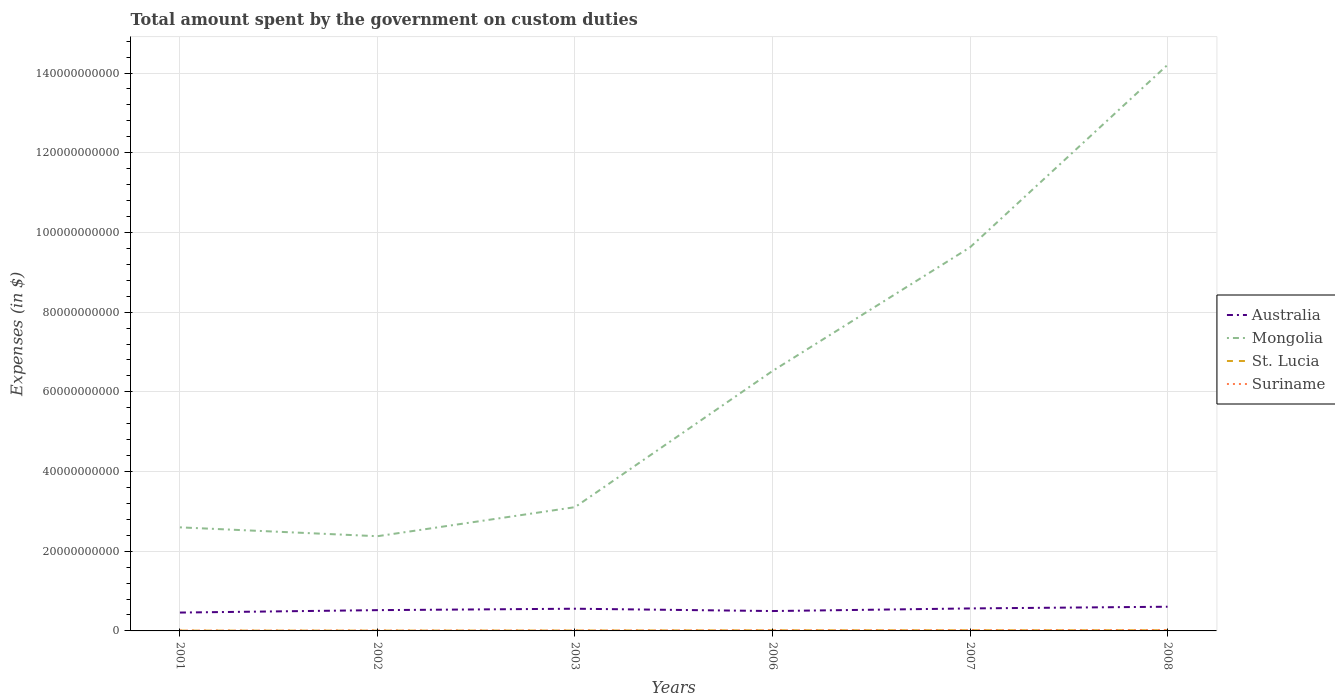How many different coloured lines are there?
Offer a very short reply. 4. Does the line corresponding to Australia intersect with the line corresponding to St. Lucia?
Give a very brief answer. No. Is the number of lines equal to the number of legend labels?
Ensure brevity in your answer.  Yes. Across all years, what is the maximum amount spent on custom duties by the government in Suriname?
Make the answer very short. 9.11e+07. In which year was the amount spent on custom duties by the government in St. Lucia maximum?
Your response must be concise. 2002. What is the total amount spent on custom duties by the government in Mongolia in the graph?
Offer a terse response. -1.18e+11. What is the difference between the highest and the second highest amount spent on custom duties by the government in Suriname?
Your answer should be very brief. 1.31e+08. What is the difference between the highest and the lowest amount spent on custom duties by the government in Suriname?
Give a very brief answer. 3. What is the difference between two consecutive major ticks on the Y-axis?
Your response must be concise. 2.00e+1. Where does the legend appear in the graph?
Make the answer very short. Center right. How are the legend labels stacked?
Your answer should be very brief. Vertical. What is the title of the graph?
Keep it short and to the point. Total amount spent by the government on custom duties. What is the label or title of the X-axis?
Your response must be concise. Years. What is the label or title of the Y-axis?
Your answer should be very brief. Expenses (in $). What is the Expenses (in $) in Australia in 2001?
Your answer should be very brief. 4.61e+09. What is the Expenses (in $) of Mongolia in 2001?
Ensure brevity in your answer.  2.60e+1. What is the Expenses (in $) of St. Lucia in 2001?
Provide a short and direct response. 8.25e+07. What is the Expenses (in $) of Suriname in 2001?
Ensure brevity in your answer.  9.11e+07. What is the Expenses (in $) in Australia in 2002?
Ensure brevity in your answer.  5.21e+09. What is the Expenses (in $) in Mongolia in 2002?
Provide a succinct answer. 2.38e+1. What is the Expenses (in $) in St. Lucia in 2002?
Your answer should be very brief. 8.15e+07. What is the Expenses (in $) in Suriname in 2002?
Provide a short and direct response. 1.07e+08. What is the Expenses (in $) in Australia in 2003?
Your answer should be very brief. 5.57e+09. What is the Expenses (in $) of Mongolia in 2003?
Your answer should be compact. 3.11e+1. What is the Expenses (in $) in St. Lucia in 2003?
Your answer should be very brief. 1.07e+08. What is the Expenses (in $) in Suriname in 2003?
Provide a succinct answer. 1.19e+08. What is the Expenses (in $) in Australia in 2006?
Your answer should be very brief. 4.99e+09. What is the Expenses (in $) of Mongolia in 2006?
Offer a very short reply. 6.52e+1. What is the Expenses (in $) of St. Lucia in 2006?
Provide a succinct answer. 1.60e+08. What is the Expenses (in $) in Suriname in 2006?
Keep it short and to the point. 1.60e+08. What is the Expenses (in $) in Australia in 2007?
Offer a terse response. 5.64e+09. What is the Expenses (in $) in Mongolia in 2007?
Give a very brief answer. 9.63e+1. What is the Expenses (in $) in St. Lucia in 2007?
Provide a succinct answer. 1.72e+08. What is the Expenses (in $) in Suriname in 2007?
Provide a succinct answer. 1.85e+08. What is the Expenses (in $) of Australia in 2008?
Your answer should be very brief. 6.07e+09. What is the Expenses (in $) in Mongolia in 2008?
Provide a succinct answer. 1.42e+11. What is the Expenses (in $) in St. Lucia in 2008?
Offer a very short reply. 1.75e+08. What is the Expenses (in $) in Suriname in 2008?
Make the answer very short. 2.22e+08. Across all years, what is the maximum Expenses (in $) in Australia?
Give a very brief answer. 6.07e+09. Across all years, what is the maximum Expenses (in $) of Mongolia?
Provide a succinct answer. 1.42e+11. Across all years, what is the maximum Expenses (in $) in St. Lucia?
Your answer should be very brief. 1.75e+08. Across all years, what is the maximum Expenses (in $) of Suriname?
Make the answer very short. 2.22e+08. Across all years, what is the minimum Expenses (in $) in Australia?
Offer a very short reply. 4.61e+09. Across all years, what is the minimum Expenses (in $) in Mongolia?
Your answer should be very brief. 2.38e+1. Across all years, what is the minimum Expenses (in $) of St. Lucia?
Your answer should be compact. 8.15e+07. Across all years, what is the minimum Expenses (in $) of Suriname?
Provide a short and direct response. 9.11e+07. What is the total Expenses (in $) in Australia in the graph?
Provide a succinct answer. 3.21e+1. What is the total Expenses (in $) of Mongolia in the graph?
Ensure brevity in your answer.  3.84e+11. What is the total Expenses (in $) in St. Lucia in the graph?
Give a very brief answer. 7.78e+08. What is the total Expenses (in $) of Suriname in the graph?
Keep it short and to the point. 8.84e+08. What is the difference between the Expenses (in $) of Australia in 2001 and that in 2002?
Ensure brevity in your answer.  -6.08e+08. What is the difference between the Expenses (in $) of Mongolia in 2001 and that in 2002?
Provide a succinct answer. 2.22e+09. What is the difference between the Expenses (in $) of St. Lucia in 2001 and that in 2002?
Make the answer very short. 1.00e+06. What is the difference between the Expenses (in $) in Suriname in 2001 and that in 2002?
Keep it short and to the point. -1.61e+07. What is the difference between the Expenses (in $) in Australia in 2001 and that in 2003?
Provide a short and direct response. -9.67e+08. What is the difference between the Expenses (in $) in Mongolia in 2001 and that in 2003?
Your response must be concise. -5.07e+09. What is the difference between the Expenses (in $) of St. Lucia in 2001 and that in 2003?
Ensure brevity in your answer.  -2.45e+07. What is the difference between the Expenses (in $) in Suriname in 2001 and that in 2003?
Your response must be concise. -2.77e+07. What is the difference between the Expenses (in $) of Australia in 2001 and that in 2006?
Give a very brief answer. -3.82e+08. What is the difference between the Expenses (in $) of Mongolia in 2001 and that in 2006?
Offer a terse response. -3.92e+1. What is the difference between the Expenses (in $) in St. Lucia in 2001 and that in 2006?
Your answer should be compact. -7.73e+07. What is the difference between the Expenses (in $) of Suriname in 2001 and that in 2006?
Keep it short and to the point. -6.90e+07. What is the difference between the Expenses (in $) of Australia in 2001 and that in 2007?
Make the answer very short. -1.04e+09. What is the difference between the Expenses (in $) of Mongolia in 2001 and that in 2007?
Your answer should be compact. -7.03e+1. What is the difference between the Expenses (in $) in St. Lucia in 2001 and that in 2007?
Provide a succinct answer. -8.96e+07. What is the difference between the Expenses (in $) in Suriname in 2001 and that in 2007?
Your answer should be very brief. -9.37e+07. What is the difference between the Expenses (in $) in Australia in 2001 and that in 2008?
Keep it short and to the point. -1.46e+09. What is the difference between the Expenses (in $) in Mongolia in 2001 and that in 2008?
Your response must be concise. -1.16e+11. What is the difference between the Expenses (in $) in St. Lucia in 2001 and that in 2008?
Your answer should be very brief. -9.29e+07. What is the difference between the Expenses (in $) of Suriname in 2001 and that in 2008?
Make the answer very short. -1.31e+08. What is the difference between the Expenses (in $) in Australia in 2002 and that in 2003?
Your response must be concise. -3.59e+08. What is the difference between the Expenses (in $) in Mongolia in 2002 and that in 2003?
Your answer should be very brief. -7.29e+09. What is the difference between the Expenses (in $) of St. Lucia in 2002 and that in 2003?
Ensure brevity in your answer.  -2.55e+07. What is the difference between the Expenses (in $) of Suriname in 2002 and that in 2003?
Provide a succinct answer. -1.16e+07. What is the difference between the Expenses (in $) of Australia in 2002 and that in 2006?
Offer a terse response. 2.26e+08. What is the difference between the Expenses (in $) of Mongolia in 2002 and that in 2006?
Provide a succinct answer. -4.15e+1. What is the difference between the Expenses (in $) in St. Lucia in 2002 and that in 2006?
Your answer should be very brief. -7.83e+07. What is the difference between the Expenses (in $) of Suriname in 2002 and that in 2006?
Provide a short and direct response. -5.29e+07. What is the difference between the Expenses (in $) of Australia in 2002 and that in 2007?
Provide a succinct answer. -4.30e+08. What is the difference between the Expenses (in $) of Mongolia in 2002 and that in 2007?
Give a very brief answer. -7.25e+1. What is the difference between the Expenses (in $) of St. Lucia in 2002 and that in 2007?
Offer a very short reply. -9.06e+07. What is the difference between the Expenses (in $) in Suriname in 2002 and that in 2007?
Your answer should be very brief. -7.76e+07. What is the difference between the Expenses (in $) in Australia in 2002 and that in 2008?
Give a very brief answer. -8.56e+08. What is the difference between the Expenses (in $) of Mongolia in 2002 and that in 2008?
Your answer should be compact. -1.18e+11. What is the difference between the Expenses (in $) of St. Lucia in 2002 and that in 2008?
Offer a terse response. -9.39e+07. What is the difference between the Expenses (in $) of Suriname in 2002 and that in 2008?
Offer a very short reply. -1.15e+08. What is the difference between the Expenses (in $) in Australia in 2003 and that in 2006?
Provide a short and direct response. 5.85e+08. What is the difference between the Expenses (in $) in Mongolia in 2003 and that in 2006?
Your response must be concise. -3.42e+1. What is the difference between the Expenses (in $) in St. Lucia in 2003 and that in 2006?
Provide a succinct answer. -5.28e+07. What is the difference between the Expenses (in $) of Suriname in 2003 and that in 2006?
Offer a terse response. -4.13e+07. What is the difference between the Expenses (in $) of Australia in 2003 and that in 2007?
Offer a very short reply. -7.10e+07. What is the difference between the Expenses (in $) in Mongolia in 2003 and that in 2007?
Ensure brevity in your answer.  -6.52e+1. What is the difference between the Expenses (in $) of St. Lucia in 2003 and that in 2007?
Your answer should be compact. -6.51e+07. What is the difference between the Expenses (in $) in Suriname in 2003 and that in 2007?
Give a very brief answer. -6.61e+07. What is the difference between the Expenses (in $) in Australia in 2003 and that in 2008?
Offer a terse response. -4.97e+08. What is the difference between the Expenses (in $) in Mongolia in 2003 and that in 2008?
Provide a succinct answer. -1.11e+11. What is the difference between the Expenses (in $) in St. Lucia in 2003 and that in 2008?
Keep it short and to the point. -6.84e+07. What is the difference between the Expenses (in $) of Suriname in 2003 and that in 2008?
Your answer should be compact. -1.03e+08. What is the difference between the Expenses (in $) in Australia in 2006 and that in 2007?
Offer a very short reply. -6.56e+08. What is the difference between the Expenses (in $) of Mongolia in 2006 and that in 2007?
Make the answer very short. -3.10e+1. What is the difference between the Expenses (in $) in St. Lucia in 2006 and that in 2007?
Your answer should be compact. -1.23e+07. What is the difference between the Expenses (in $) in Suriname in 2006 and that in 2007?
Your response must be concise. -2.47e+07. What is the difference between the Expenses (in $) of Australia in 2006 and that in 2008?
Provide a short and direct response. -1.08e+09. What is the difference between the Expenses (in $) of Mongolia in 2006 and that in 2008?
Provide a succinct answer. -7.68e+1. What is the difference between the Expenses (in $) in St. Lucia in 2006 and that in 2008?
Give a very brief answer. -1.56e+07. What is the difference between the Expenses (in $) in Suriname in 2006 and that in 2008?
Your answer should be very brief. -6.18e+07. What is the difference between the Expenses (in $) of Australia in 2007 and that in 2008?
Offer a terse response. -4.26e+08. What is the difference between the Expenses (in $) in Mongolia in 2007 and that in 2008?
Your answer should be compact. -4.58e+1. What is the difference between the Expenses (in $) in St. Lucia in 2007 and that in 2008?
Offer a terse response. -3.30e+06. What is the difference between the Expenses (in $) of Suriname in 2007 and that in 2008?
Your response must be concise. -3.71e+07. What is the difference between the Expenses (in $) of Australia in 2001 and the Expenses (in $) of Mongolia in 2002?
Keep it short and to the point. -1.92e+1. What is the difference between the Expenses (in $) of Australia in 2001 and the Expenses (in $) of St. Lucia in 2002?
Provide a succinct answer. 4.52e+09. What is the difference between the Expenses (in $) of Australia in 2001 and the Expenses (in $) of Suriname in 2002?
Your answer should be very brief. 4.50e+09. What is the difference between the Expenses (in $) in Mongolia in 2001 and the Expenses (in $) in St. Lucia in 2002?
Your response must be concise. 2.59e+1. What is the difference between the Expenses (in $) in Mongolia in 2001 and the Expenses (in $) in Suriname in 2002?
Offer a very short reply. 2.59e+1. What is the difference between the Expenses (in $) in St. Lucia in 2001 and the Expenses (in $) in Suriname in 2002?
Your response must be concise. -2.47e+07. What is the difference between the Expenses (in $) of Australia in 2001 and the Expenses (in $) of Mongolia in 2003?
Make the answer very short. -2.65e+1. What is the difference between the Expenses (in $) of Australia in 2001 and the Expenses (in $) of St. Lucia in 2003?
Offer a very short reply. 4.50e+09. What is the difference between the Expenses (in $) of Australia in 2001 and the Expenses (in $) of Suriname in 2003?
Provide a succinct answer. 4.49e+09. What is the difference between the Expenses (in $) of Mongolia in 2001 and the Expenses (in $) of St. Lucia in 2003?
Your response must be concise. 2.59e+1. What is the difference between the Expenses (in $) of Mongolia in 2001 and the Expenses (in $) of Suriname in 2003?
Your answer should be very brief. 2.59e+1. What is the difference between the Expenses (in $) of St. Lucia in 2001 and the Expenses (in $) of Suriname in 2003?
Provide a short and direct response. -3.62e+07. What is the difference between the Expenses (in $) in Australia in 2001 and the Expenses (in $) in Mongolia in 2006?
Your response must be concise. -6.06e+1. What is the difference between the Expenses (in $) in Australia in 2001 and the Expenses (in $) in St. Lucia in 2006?
Offer a very short reply. 4.45e+09. What is the difference between the Expenses (in $) of Australia in 2001 and the Expenses (in $) of Suriname in 2006?
Make the answer very short. 4.45e+09. What is the difference between the Expenses (in $) of Mongolia in 2001 and the Expenses (in $) of St. Lucia in 2006?
Keep it short and to the point. 2.58e+1. What is the difference between the Expenses (in $) of Mongolia in 2001 and the Expenses (in $) of Suriname in 2006?
Keep it short and to the point. 2.58e+1. What is the difference between the Expenses (in $) of St. Lucia in 2001 and the Expenses (in $) of Suriname in 2006?
Your answer should be very brief. -7.76e+07. What is the difference between the Expenses (in $) of Australia in 2001 and the Expenses (in $) of Mongolia in 2007?
Your response must be concise. -9.17e+1. What is the difference between the Expenses (in $) in Australia in 2001 and the Expenses (in $) in St. Lucia in 2007?
Your answer should be very brief. 4.43e+09. What is the difference between the Expenses (in $) of Australia in 2001 and the Expenses (in $) of Suriname in 2007?
Your answer should be very brief. 4.42e+09. What is the difference between the Expenses (in $) of Mongolia in 2001 and the Expenses (in $) of St. Lucia in 2007?
Offer a very short reply. 2.58e+1. What is the difference between the Expenses (in $) of Mongolia in 2001 and the Expenses (in $) of Suriname in 2007?
Your response must be concise. 2.58e+1. What is the difference between the Expenses (in $) of St. Lucia in 2001 and the Expenses (in $) of Suriname in 2007?
Give a very brief answer. -1.02e+08. What is the difference between the Expenses (in $) of Australia in 2001 and the Expenses (in $) of Mongolia in 2008?
Keep it short and to the point. -1.37e+11. What is the difference between the Expenses (in $) in Australia in 2001 and the Expenses (in $) in St. Lucia in 2008?
Keep it short and to the point. 4.43e+09. What is the difference between the Expenses (in $) of Australia in 2001 and the Expenses (in $) of Suriname in 2008?
Make the answer very short. 4.38e+09. What is the difference between the Expenses (in $) in Mongolia in 2001 and the Expenses (in $) in St. Lucia in 2008?
Provide a succinct answer. 2.58e+1. What is the difference between the Expenses (in $) in Mongolia in 2001 and the Expenses (in $) in Suriname in 2008?
Your response must be concise. 2.58e+1. What is the difference between the Expenses (in $) in St. Lucia in 2001 and the Expenses (in $) in Suriname in 2008?
Give a very brief answer. -1.39e+08. What is the difference between the Expenses (in $) of Australia in 2002 and the Expenses (in $) of Mongolia in 2003?
Provide a succinct answer. -2.58e+1. What is the difference between the Expenses (in $) of Australia in 2002 and the Expenses (in $) of St. Lucia in 2003?
Your response must be concise. 5.11e+09. What is the difference between the Expenses (in $) in Australia in 2002 and the Expenses (in $) in Suriname in 2003?
Make the answer very short. 5.10e+09. What is the difference between the Expenses (in $) of Mongolia in 2002 and the Expenses (in $) of St. Lucia in 2003?
Keep it short and to the point. 2.37e+1. What is the difference between the Expenses (in $) of Mongolia in 2002 and the Expenses (in $) of Suriname in 2003?
Your answer should be very brief. 2.36e+1. What is the difference between the Expenses (in $) in St. Lucia in 2002 and the Expenses (in $) in Suriname in 2003?
Your response must be concise. -3.72e+07. What is the difference between the Expenses (in $) in Australia in 2002 and the Expenses (in $) in Mongolia in 2006?
Ensure brevity in your answer.  -6.00e+1. What is the difference between the Expenses (in $) in Australia in 2002 and the Expenses (in $) in St. Lucia in 2006?
Your answer should be compact. 5.05e+09. What is the difference between the Expenses (in $) of Australia in 2002 and the Expenses (in $) of Suriname in 2006?
Give a very brief answer. 5.05e+09. What is the difference between the Expenses (in $) of Mongolia in 2002 and the Expenses (in $) of St. Lucia in 2006?
Your answer should be very brief. 2.36e+1. What is the difference between the Expenses (in $) of Mongolia in 2002 and the Expenses (in $) of Suriname in 2006?
Give a very brief answer. 2.36e+1. What is the difference between the Expenses (in $) of St. Lucia in 2002 and the Expenses (in $) of Suriname in 2006?
Make the answer very short. -7.86e+07. What is the difference between the Expenses (in $) of Australia in 2002 and the Expenses (in $) of Mongolia in 2007?
Provide a succinct answer. -9.10e+1. What is the difference between the Expenses (in $) of Australia in 2002 and the Expenses (in $) of St. Lucia in 2007?
Offer a terse response. 5.04e+09. What is the difference between the Expenses (in $) of Australia in 2002 and the Expenses (in $) of Suriname in 2007?
Keep it short and to the point. 5.03e+09. What is the difference between the Expenses (in $) of Mongolia in 2002 and the Expenses (in $) of St. Lucia in 2007?
Ensure brevity in your answer.  2.36e+1. What is the difference between the Expenses (in $) of Mongolia in 2002 and the Expenses (in $) of Suriname in 2007?
Provide a short and direct response. 2.36e+1. What is the difference between the Expenses (in $) in St. Lucia in 2002 and the Expenses (in $) in Suriname in 2007?
Offer a very short reply. -1.03e+08. What is the difference between the Expenses (in $) of Australia in 2002 and the Expenses (in $) of Mongolia in 2008?
Offer a terse response. -1.37e+11. What is the difference between the Expenses (in $) of Australia in 2002 and the Expenses (in $) of St. Lucia in 2008?
Offer a very short reply. 5.04e+09. What is the difference between the Expenses (in $) in Australia in 2002 and the Expenses (in $) in Suriname in 2008?
Give a very brief answer. 4.99e+09. What is the difference between the Expenses (in $) in Mongolia in 2002 and the Expenses (in $) in St. Lucia in 2008?
Make the answer very short. 2.36e+1. What is the difference between the Expenses (in $) of Mongolia in 2002 and the Expenses (in $) of Suriname in 2008?
Offer a terse response. 2.35e+1. What is the difference between the Expenses (in $) of St. Lucia in 2002 and the Expenses (in $) of Suriname in 2008?
Provide a succinct answer. -1.40e+08. What is the difference between the Expenses (in $) of Australia in 2003 and the Expenses (in $) of Mongolia in 2006?
Your answer should be very brief. -5.97e+1. What is the difference between the Expenses (in $) in Australia in 2003 and the Expenses (in $) in St. Lucia in 2006?
Your answer should be compact. 5.41e+09. What is the difference between the Expenses (in $) of Australia in 2003 and the Expenses (in $) of Suriname in 2006?
Give a very brief answer. 5.41e+09. What is the difference between the Expenses (in $) in Mongolia in 2003 and the Expenses (in $) in St. Lucia in 2006?
Make the answer very short. 3.09e+1. What is the difference between the Expenses (in $) of Mongolia in 2003 and the Expenses (in $) of Suriname in 2006?
Make the answer very short. 3.09e+1. What is the difference between the Expenses (in $) in St. Lucia in 2003 and the Expenses (in $) in Suriname in 2006?
Provide a short and direct response. -5.31e+07. What is the difference between the Expenses (in $) in Australia in 2003 and the Expenses (in $) in Mongolia in 2007?
Provide a short and direct response. -9.07e+1. What is the difference between the Expenses (in $) of Australia in 2003 and the Expenses (in $) of St. Lucia in 2007?
Offer a very short reply. 5.40e+09. What is the difference between the Expenses (in $) in Australia in 2003 and the Expenses (in $) in Suriname in 2007?
Provide a succinct answer. 5.39e+09. What is the difference between the Expenses (in $) in Mongolia in 2003 and the Expenses (in $) in St. Lucia in 2007?
Offer a very short reply. 3.09e+1. What is the difference between the Expenses (in $) in Mongolia in 2003 and the Expenses (in $) in Suriname in 2007?
Provide a short and direct response. 3.09e+1. What is the difference between the Expenses (in $) in St. Lucia in 2003 and the Expenses (in $) in Suriname in 2007?
Make the answer very short. -7.78e+07. What is the difference between the Expenses (in $) of Australia in 2003 and the Expenses (in $) of Mongolia in 2008?
Your answer should be very brief. -1.36e+11. What is the difference between the Expenses (in $) in Australia in 2003 and the Expenses (in $) in St. Lucia in 2008?
Ensure brevity in your answer.  5.40e+09. What is the difference between the Expenses (in $) in Australia in 2003 and the Expenses (in $) in Suriname in 2008?
Keep it short and to the point. 5.35e+09. What is the difference between the Expenses (in $) of Mongolia in 2003 and the Expenses (in $) of St. Lucia in 2008?
Your response must be concise. 3.09e+1. What is the difference between the Expenses (in $) of Mongolia in 2003 and the Expenses (in $) of Suriname in 2008?
Your answer should be compact. 3.08e+1. What is the difference between the Expenses (in $) in St. Lucia in 2003 and the Expenses (in $) in Suriname in 2008?
Provide a short and direct response. -1.15e+08. What is the difference between the Expenses (in $) of Australia in 2006 and the Expenses (in $) of Mongolia in 2007?
Give a very brief answer. -9.13e+1. What is the difference between the Expenses (in $) of Australia in 2006 and the Expenses (in $) of St. Lucia in 2007?
Make the answer very short. 4.82e+09. What is the difference between the Expenses (in $) of Australia in 2006 and the Expenses (in $) of Suriname in 2007?
Give a very brief answer. 4.80e+09. What is the difference between the Expenses (in $) in Mongolia in 2006 and the Expenses (in $) in St. Lucia in 2007?
Your response must be concise. 6.51e+1. What is the difference between the Expenses (in $) in Mongolia in 2006 and the Expenses (in $) in Suriname in 2007?
Your answer should be very brief. 6.50e+1. What is the difference between the Expenses (in $) in St. Lucia in 2006 and the Expenses (in $) in Suriname in 2007?
Your answer should be very brief. -2.50e+07. What is the difference between the Expenses (in $) in Australia in 2006 and the Expenses (in $) in Mongolia in 2008?
Ensure brevity in your answer.  -1.37e+11. What is the difference between the Expenses (in $) in Australia in 2006 and the Expenses (in $) in St. Lucia in 2008?
Make the answer very short. 4.81e+09. What is the difference between the Expenses (in $) in Australia in 2006 and the Expenses (in $) in Suriname in 2008?
Offer a terse response. 4.77e+09. What is the difference between the Expenses (in $) of Mongolia in 2006 and the Expenses (in $) of St. Lucia in 2008?
Offer a terse response. 6.51e+1. What is the difference between the Expenses (in $) in Mongolia in 2006 and the Expenses (in $) in Suriname in 2008?
Your answer should be very brief. 6.50e+1. What is the difference between the Expenses (in $) of St. Lucia in 2006 and the Expenses (in $) of Suriname in 2008?
Ensure brevity in your answer.  -6.21e+07. What is the difference between the Expenses (in $) in Australia in 2007 and the Expenses (in $) in Mongolia in 2008?
Ensure brevity in your answer.  -1.36e+11. What is the difference between the Expenses (in $) of Australia in 2007 and the Expenses (in $) of St. Lucia in 2008?
Your response must be concise. 5.47e+09. What is the difference between the Expenses (in $) in Australia in 2007 and the Expenses (in $) in Suriname in 2008?
Your answer should be very brief. 5.42e+09. What is the difference between the Expenses (in $) in Mongolia in 2007 and the Expenses (in $) in St. Lucia in 2008?
Make the answer very short. 9.61e+1. What is the difference between the Expenses (in $) of Mongolia in 2007 and the Expenses (in $) of Suriname in 2008?
Give a very brief answer. 9.60e+1. What is the difference between the Expenses (in $) in St. Lucia in 2007 and the Expenses (in $) in Suriname in 2008?
Keep it short and to the point. -4.98e+07. What is the average Expenses (in $) of Australia per year?
Your response must be concise. 5.35e+09. What is the average Expenses (in $) in Mongolia per year?
Provide a succinct answer. 6.41e+1. What is the average Expenses (in $) in St. Lucia per year?
Give a very brief answer. 1.30e+08. What is the average Expenses (in $) of Suriname per year?
Offer a very short reply. 1.47e+08. In the year 2001, what is the difference between the Expenses (in $) of Australia and Expenses (in $) of Mongolia?
Keep it short and to the point. -2.14e+1. In the year 2001, what is the difference between the Expenses (in $) of Australia and Expenses (in $) of St. Lucia?
Your response must be concise. 4.52e+09. In the year 2001, what is the difference between the Expenses (in $) of Australia and Expenses (in $) of Suriname?
Your answer should be very brief. 4.51e+09. In the year 2001, what is the difference between the Expenses (in $) in Mongolia and Expenses (in $) in St. Lucia?
Ensure brevity in your answer.  2.59e+1. In the year 2001, what is the difference between the Expenses (in $) of Mongolia and Expenses (in $) of Suriname?
Ensure brevity in your answer.  2.59e+1. In the year 2001, what is the difference between the Expenses (in $) of St. Lucia and Expenses (in $) of Suriname?
Keep it short and to the point. -8.56e+06. In the year 2002, what is the difference between the Expenses (in $) in Australia and Expenses (in $) in Mongolia?
Offer a very short reply. -1.86e+1. In the year 2002, what is the difference between the Expenses (in $) in Australia and Expenses (in $) in St. Lucia?
Make the answer very short. 5.13e+09. In the year 2002, what is the difference between the Expenses (in $) in Australia and Expenses (in $) in Suriname?
Keep it short and to the point. 5.11e+09. In the year 2002, what is the difference between the Expenses (in $) in Mongolia and Expenses (in $) in St. Lucia?
Provide a succinct answer. 2.37e+1. In the year 2002, what is the difference between the Expenses (in $) in Mongolia and Expenses (in $) in Suriname?
Ensure brevity in your answer.  2.37e+1. In the year 2002, what is the difference between the Expenses (in $) of St. Lucia and Expenses (in $) of Suriname?
Keep it short and to the point. -2.57e+07. In the year 2003, what is the difference between the Expenses (in $) in Australia and Expenses (in $) in Mongolia?
Provide a short and direct response. -2.55e+1. In the year 2003, what is the difference between the Expenses (in $) of Australia and Expenses (in $) of St. Lucia?
Your answer should be compact. 5.47e+09. In the year 2003, what is the difference between the Expenses (in $) of Australia and Expenses (in $) of Suriname?
Give a very brief answer. 5.45e+09. In the year 2003, what is the difference between the Expenses (in $) of Mongolia and Expenses (in $) of St. Lucia?
Provide a short and direct response. 3.10e+1. In the year 2003, what is the difference between the Expenses (in $) of Mongolia and Expenses (in $) of Suriname?
Your answer should be compact. 3.09e+1. In the year 2003, what is the difference between the Expenses (in $) of St. Lucia and Expenses (in $) of Suriname?
Keep it short and to the point. -1.17e+07. In the year 2006, what is the difference between the Expenses (in $) of Australia and Expenses (in $) of Mongolia?
Provide a short and direct response. -6.02e+1. In the year 2006, what is the difference between the Expenses (in $) in Australia and Expenses (in $) in St. Lucia?
Make the answer very short. 4.83e+09. In the year 2006, what is the difference between the Expenses (in $) in Australia and Expenses (in $) in Suriname?
Your answer should be compact. 4.83e+09. In the year 2006, what is the difference between the Expenses (in $) in Mongolia and Expenses (in $) in St. Lucia?
Ensure brevity in your answer.  6.51e+1. In the year 2006, what is the difference between the Expenses (in $) of Mongolia and Expenses (in $) of Suriname?
Provide a succinct answer. 6.51e+1. In the year 2006, what is the difference between the Expenses (in $) in St. Lucia and Expenses (in $) in Suriname?
Offer a very short reply. -2.60e+05. In the year 2007, what is the difference between the Expenses (in $) of Australia and Expenses (in $) of Mongolia?
Keep it short and to the point. -9.06e+1. In the year 2007, what is the difference between the Expenses (in $) in Australia and Expenses (in $) in St. Lucia?
Your response must be concise. 5.47e+09. In the year 2007, what is the difference between the Expenses (in $) in Australia and Expenses (in $) in Suriname?
Make the answer very short. 5.46e+09. In the year 2007, what is the difference between the Expenses (in $) of Mongolia and Expenses (in $) of St. Lucia?
Keep it short and to the point. 9.61e+1. In the year 2007, what is the difference between the Expenses (in $) in Mongolia and Expenses (in $) in Suriname?
Provide a short and direct response. 9.61e+1. In the year 2007, what is the difference between the Expenses (in $) in St. Lucia and Expenses (in $) in Suriname?
Your answer should be very brief. -1.27e+07. In the year 2008, what is the difference between the Expenses (in $) of Australia and Expenses (in $) of Mongolia?
Make the answer very short. -1.36e+11. In the year 2008, what is the difference between the Expenses (in $) of Australia and Expenses (in $) of St. Lucia?
Your answer should be very brief. 5.89e+09. In the year 2008, what is the difference between the Expenses (in $) of Australia and Expenses (in $) of Suriname?
Make the answer very short. 5.85e+09. In the year 2008, what is the difference between the Expenses (in $) in Mongolia and Expenses (in $) in St. Lucia?
Give a very brief answer. 1.42e+11. In the year 2008, what is the difference between the Expenses (in $) in Mongolia and Expenses (in $) in Suriname?
Give a very brief answer. 1.42e+11. In the year 2008, what is the difference between the Expenses (in $) of St. Lucia and Expenses (in $) of Suriname?
Offer a very short reply. -4.65e+07. What is the ratio of the Expenses (in $) in Australia in 2001 to that in 2002?
Give a very brief answer. 0.88. What is the ratio of the Expenses (in $) in Mongolia in 2001 to that in 2002?
Provide a succinct answer. 1.09. What is the ratio of the Expenses (in $) in St. Lucia in 2001 to that in 2002?
Your answer should be compact. 1.01. What is the ratio of the Expenses (in $) of Suriname in 2001 to that in 2002?
Offer a terse response. 0.85. What is the ratio of the Expenses (in $) of Australia in 2001 to that in 2003?
Your answer should be compact. 0.83. What is the ratio of the Expenses (in $) in Mongolia in 2001 to that in 2003?
Provide a short and direct response. 0.84. What is the ratio of the Expenses (in $) in St. Lucia in 2001 to that in 2003?
Your answer should be very brief. 0.77. What is the ratio of the Expenses (in $) of Suriname in 2001 to that in 2003?
Offer a terse response. 0.77. What is the ratio of the Expenses (in $) in Australia in 2001 to that in 2006?
Make the answer very short. 0.92. What is the ratio of the Expenses (in $) of Mongolia in 2001 to that in 2006?
Your answer should be very brief. 0.4. What is the ratio of the Expenses (in $) of St. Lucia in 2001 to that in 2006?
Your answer should be compact. 0.52. What is the ratio of the Expenses (in $) of Suriname in 2001 to that in 2006?
Ensure brevity in your answer.  0.57. What is the ratio of the Expenses (in $) of Australia in 2001 to that in 2007?
Make the answer very short. 0.82. What is the ratio of the Expenses (in $) of Mongolia in 2001 to that in 2007?
Offer a terse response. 0.27. What is the ratio of the Expenses (in $) in St. Lucia in 2001 to that in 2007?
Keep it short and to the point. 0.48. What is the ratio of the Expenses (in $) in Suriname in 2001 to that in 2007?
Offer a very short reply. 0.49. What is the ratio of the Expenses (in $) of Australia in 2001 to that in 2008?
Provide a succinct answer. 0.76. What is the ratio of the Expenses (in $) of Mongolia in 2001 to that in 2008?
Your answer should be very brief. 0.18. What is the ratio of the Expenses (in $) in St. Lucia in 2001 to that in 2008?
Keep it short and to the point. 0.47. What is the ratio of the Expenses (in $) of Suriname in 2001 to that in 2008?
Your answer should be compact. 0.41. What is the ratio of the Expenses (in $) in Australia in 2002 to that in 2003?
Offer a very short reply. 0.94. What is the ratio of the Expenses (in $) in Mongolia in 2002 to that in 2003?
Provide a short and direct response. 0.77. What is the ratio of the Expenses (in $) of St. Lucia in 2002 to that in 2003?
Offer a very short reply. 0.76. What is the ratio of the Expenses (in $) in Suriname in 2002 to that in 2003?
Your answer should be very brief. 0.9. What is the ratio of the Expenses (in $) in Australia in 2002 to that in 2006?
Your response must be concise. 1.05. What is the ratio of the Expenses (in $) in Mongolia in 2002 to that in 2006?
Your response must be concise. 0.36. What is the ratio of the Expenses (in $) in St. Lucia in 2002 to that in 2006?
Give a very brief answer. 0.51. What is the ratio of the Expenses (in $) of Suriname in 2002 to that in 2006?
Your answer should be compact. 0.67. What is the ratio of the Expenses (in $) of Australia in 2002 to that in 2007?
Keep it short and to the point. 0.92. What is the ratio of the Expenses (in $) of Mongolia in 2002 to that in 2007?
Ensure brevity in your answer.  0.25. What is the ratio of the Expenses (in $) of St. Lucia in 2002 to that in 2007?
Offer a terse response. 0.47. What is the ratio of the Expenses (in $) in Suriname in 2002 to that in 2007?
Keep it short and to the point. 0.58. What is the ratio of the Expenses (in $) of Australia in 2002 to that in 2008?
Keep it short and to the point. 0.86. What is the ratio of the Expenses (in $) of Mongolia in 2002 to that in 2008?
Offer a very short reply. 0.17. What is the ratio of the Expenses (in $) of St. Lucia in 2002 to that in 2008?
Ensure brevity in your answer.  0.46. What is the ratio of the Expenses (in $) in Suriname in 2002 to that in 2008?
Ensure brevity in your answer.  0.48. What is the ratio of the Expenses (in $) of Australia in 2003 to that in 2006?
Provide a short and direct response. 1.12. What is the ratio of the Expenses (in $) in Mongolia in 2003 to that in 2006?
Offer a very short reply. 0.48. What is the ratio of the Expenses (in $) in St. Lucia in 2003 to that in 2006?
Make the answer very short. 0.67. What is the ratio of the Expenses (in $) in Suriname in 2003 to that in 2006?
Ensure brevity in your answer.  0.74. What is the ratio of the Expenses (in $) of Australia in 2003 to that in 2007?
Provide a short and direct response. 0.99. What is the ratio of the Expenses (in $) in Mongolia in 2003 to that in 2007?
Provide a succinct answer. 0.32. What is the ratio of the Expenses (in $) of St. Lucia in 2003 to that in 2007?
Offer a terse response. 0.62. What is the ratio of the Expenses (in $) in Suriname in 2003 to that in 2007?
Make the answer very short. 0.64. What is the ratio of the Expenses (in $) of Australia in 2003 to that in 2008?
Ensure brevity in your answer.  0.92. What is the ratio of the Expenses (in $) of Mongolia in 2003 to that in 2008?
Your answer should be very brief. 0.22. What is the ratio of the Expenses (in $) of St. Lucia in 2003 to that in 2008?
Offer a terse response. 0.61. What is the ratio of the Expenses (in $) in Suriname in 2003 to that in 2008?
Your answer should be compact. 0.54. What is the ratio of the Expenses (in $) in Australia in 2006 to that in 2007?
Provide a succinct answer. 0.88. What is the ratio of the Expenses (in $) in Mongolia in 2006 to that in 2007?
Keep it short and to the point. 0.68. What is the ratio of the Expenses (in $) in St. Lucia in 2006 to that in 2007?
Your answer should be compact. 0.93. What is the ratio of the Expenses (in $) in Suriname in 2006 to that in 2007?
Give a very brief answer. 0.87. What is the ratio of the Expenses (in $) of Australia in 2006 to that in 2008?
Make the answer very short. 0.82. What is the ratio of the Expenses (in $) in Mongolia in 2006 to that in 2008?
Provide a short and direct response. 0.46. What is the ratio of the Expenses (in $) of St. Lucia in 2006 to that in 2008?
Give a very brief answer. 0.91. What is the ratio of the Expenses (in $) of Suriname in 2006 to that in 2008?
Your answer should be very brief. 0.72. What is the ratio of the Expenses (in $) of Australia in 2007 to that in 2008?
Provide a succinct answer. 0.93. What is the ratio of the Expenses (in $) in Mongolia in 2007 to that in 2008?
Ensure brevity in your answer.  0.68. What is the ratio of the Expenses (in $) of St. Lucia in 2007 to that in 2008?
Offer a terse response. 0.98. What is the ratio of the Expenses (in $) in Suriname in 2007 to that in 2008?
Keep it short and to the point. 0.83. What is the difference between the highest and the second highest Expenses (in $) of Australia?
Your answer should be compact. 4.26e+08. What is the difference between the highest and the second highest Expenses (in $) in Mongolia?
Your answer should be compact. 4.58e+1. What is the difference between the highest and the second highest Expenses (in $) in St. Lucia?
Your answer should be very brief. 3.30e+06. What is the difference between the highest and the second highest Expenses (in $) in Suriname?
Provide a succinct answer. 3.71e+07. What is the difference between the highest and the lowest Expenses (in $) in Australia?
Ensure brevity in your answer.  1.46e+09. What is the difference between the highest and the lowest Expenses (in $) of Mongolia?
Ensure brevity in your answer.  1.18e+11. What is the difference between the highest and the lowest Expenses (in $) of St. Lucia?
Ensure brevity in your answer.  9.39e+07. What is the difference between the highest and the lowest Expenses (in $) of Suriname?
Ensure brevity in your answer.  1.31e+08. 